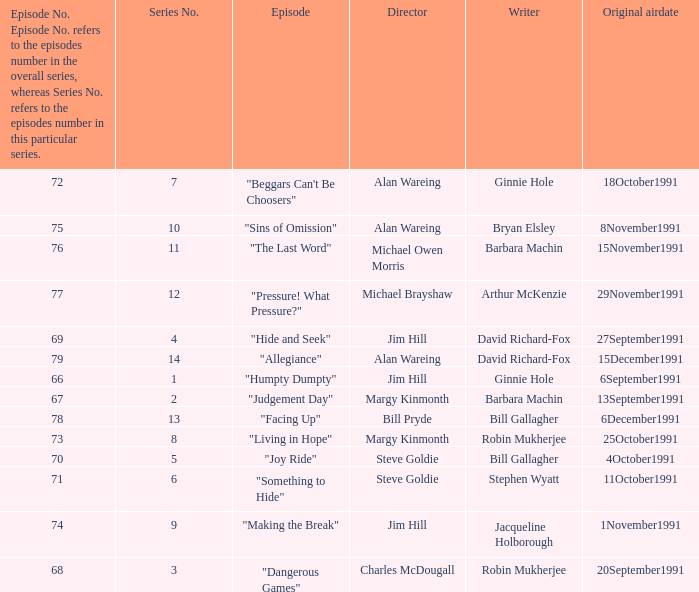Would you be able to parse every entry in this table? {'header': ['Episode No. Episode No. refers to the episodes number in the overall series, whereas Series No. refers to the episodes number in this particular series.', 'Series No.', 'Episode', 'Director', 'Writer', 'Original airdate'], 'rows': [['72', '7', '"Beggars Can\'t Be Choosers"', 'Alan Wareing', 'Ginnie Hole', '18October1991'], ['75', '10', '"Sins of Omission"', 'Alan Wareing', 'Bryan Elsley', '8November1991'], ['76', '11', '"The Last Word"', 'Michael Owen Morris', 'Barbara Machin', '15November1991'], ['77', '12', '"Pressure! What Pressure?"', 'Michael Brayshaw', 'Arthur McKenzie', '29November1991'], ['69', '4', '"Hide and Seek"', 'Jim Hill', 'David Richard-Fox', '27September1991'], ['79', '14', '"Allegiance"', 'Alan Wareing', 'David Richard-Fox', '15December1991'], ['66', '1', '"Humpty Dumpty"', 'Jim Hill', 'Ginnie Hole', '6September1991'], ['67', '2', '"Judgement Day"', 'Margy Kinmonth', 'Barbara Machin', '13September1991'], ['78', '13', '"Facing Up"', 'Bill Pryde', 'Bill Gallagher', '6December1991'], ['73', '8', '"Living in Hope"', 'Margy Kinmonth', 'Robin Mukherjee', '25October1991'], ['70', '5', '"Joy Ride"', 'Steve Goldie', 'Bill Gallagher', '4October1991'], ['71', '6', '"Something to Hide"', 'Steve Goldie', 'Stephen Wyatt', '11October1991'], ['74', '9', '"Making the Break"', 'Jim Hill', 'Jacqueline Holborough', '1November1991'], ['68', '3', '"Dangerous Games"', 'Charles McDougall', 'Robin Mukherjee', '20September1991']]} Name the least series number for episode number being 78 13.0. 